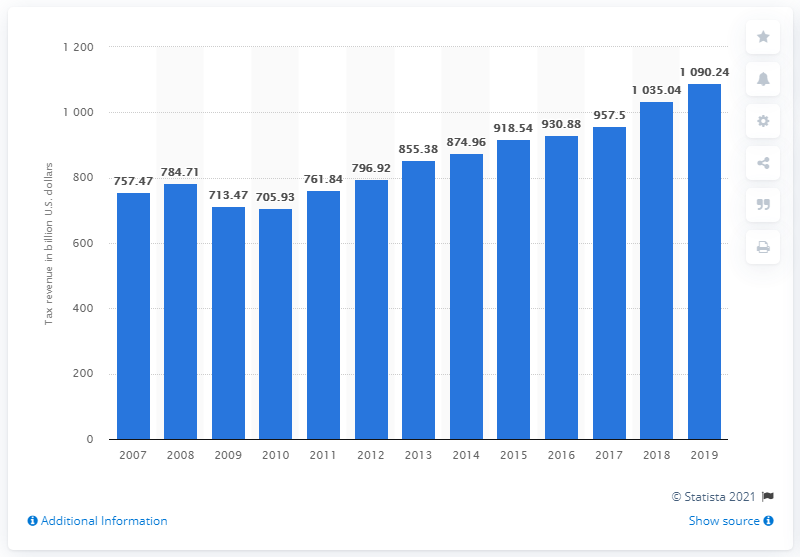Outline some significant characteristics in this image. The total amount of state tax revenues in 2019 was 1090.24. In the year 2007, state tax collections were last collected. 